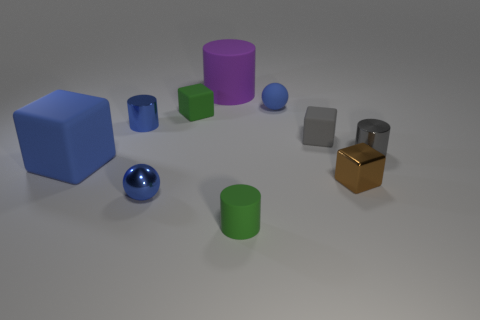Subtract all gray rubber cubes. How many cubes are left? 3 Subtract all gray cubes. How many cubes are left? 3 Add 5 small green cubes. How many small green cubes are left? 6 Add 3 large blue matte blocks. How many large blue matte blocks exist? 4 Subtract 0 yellow cubes. How many objects are left? 10 Subtract all blocks. How many objects are left? 6 Subtract 1 balls. How many balls are left? 1 Subtract all yellow cubes. Subtract all gray balls. How many cubes are left? 4 Subtract all yellow cylinders. How many blue cubes are left? 1 Subtract all green cylinders. Subtract all blocks. How many objects are left? 5 